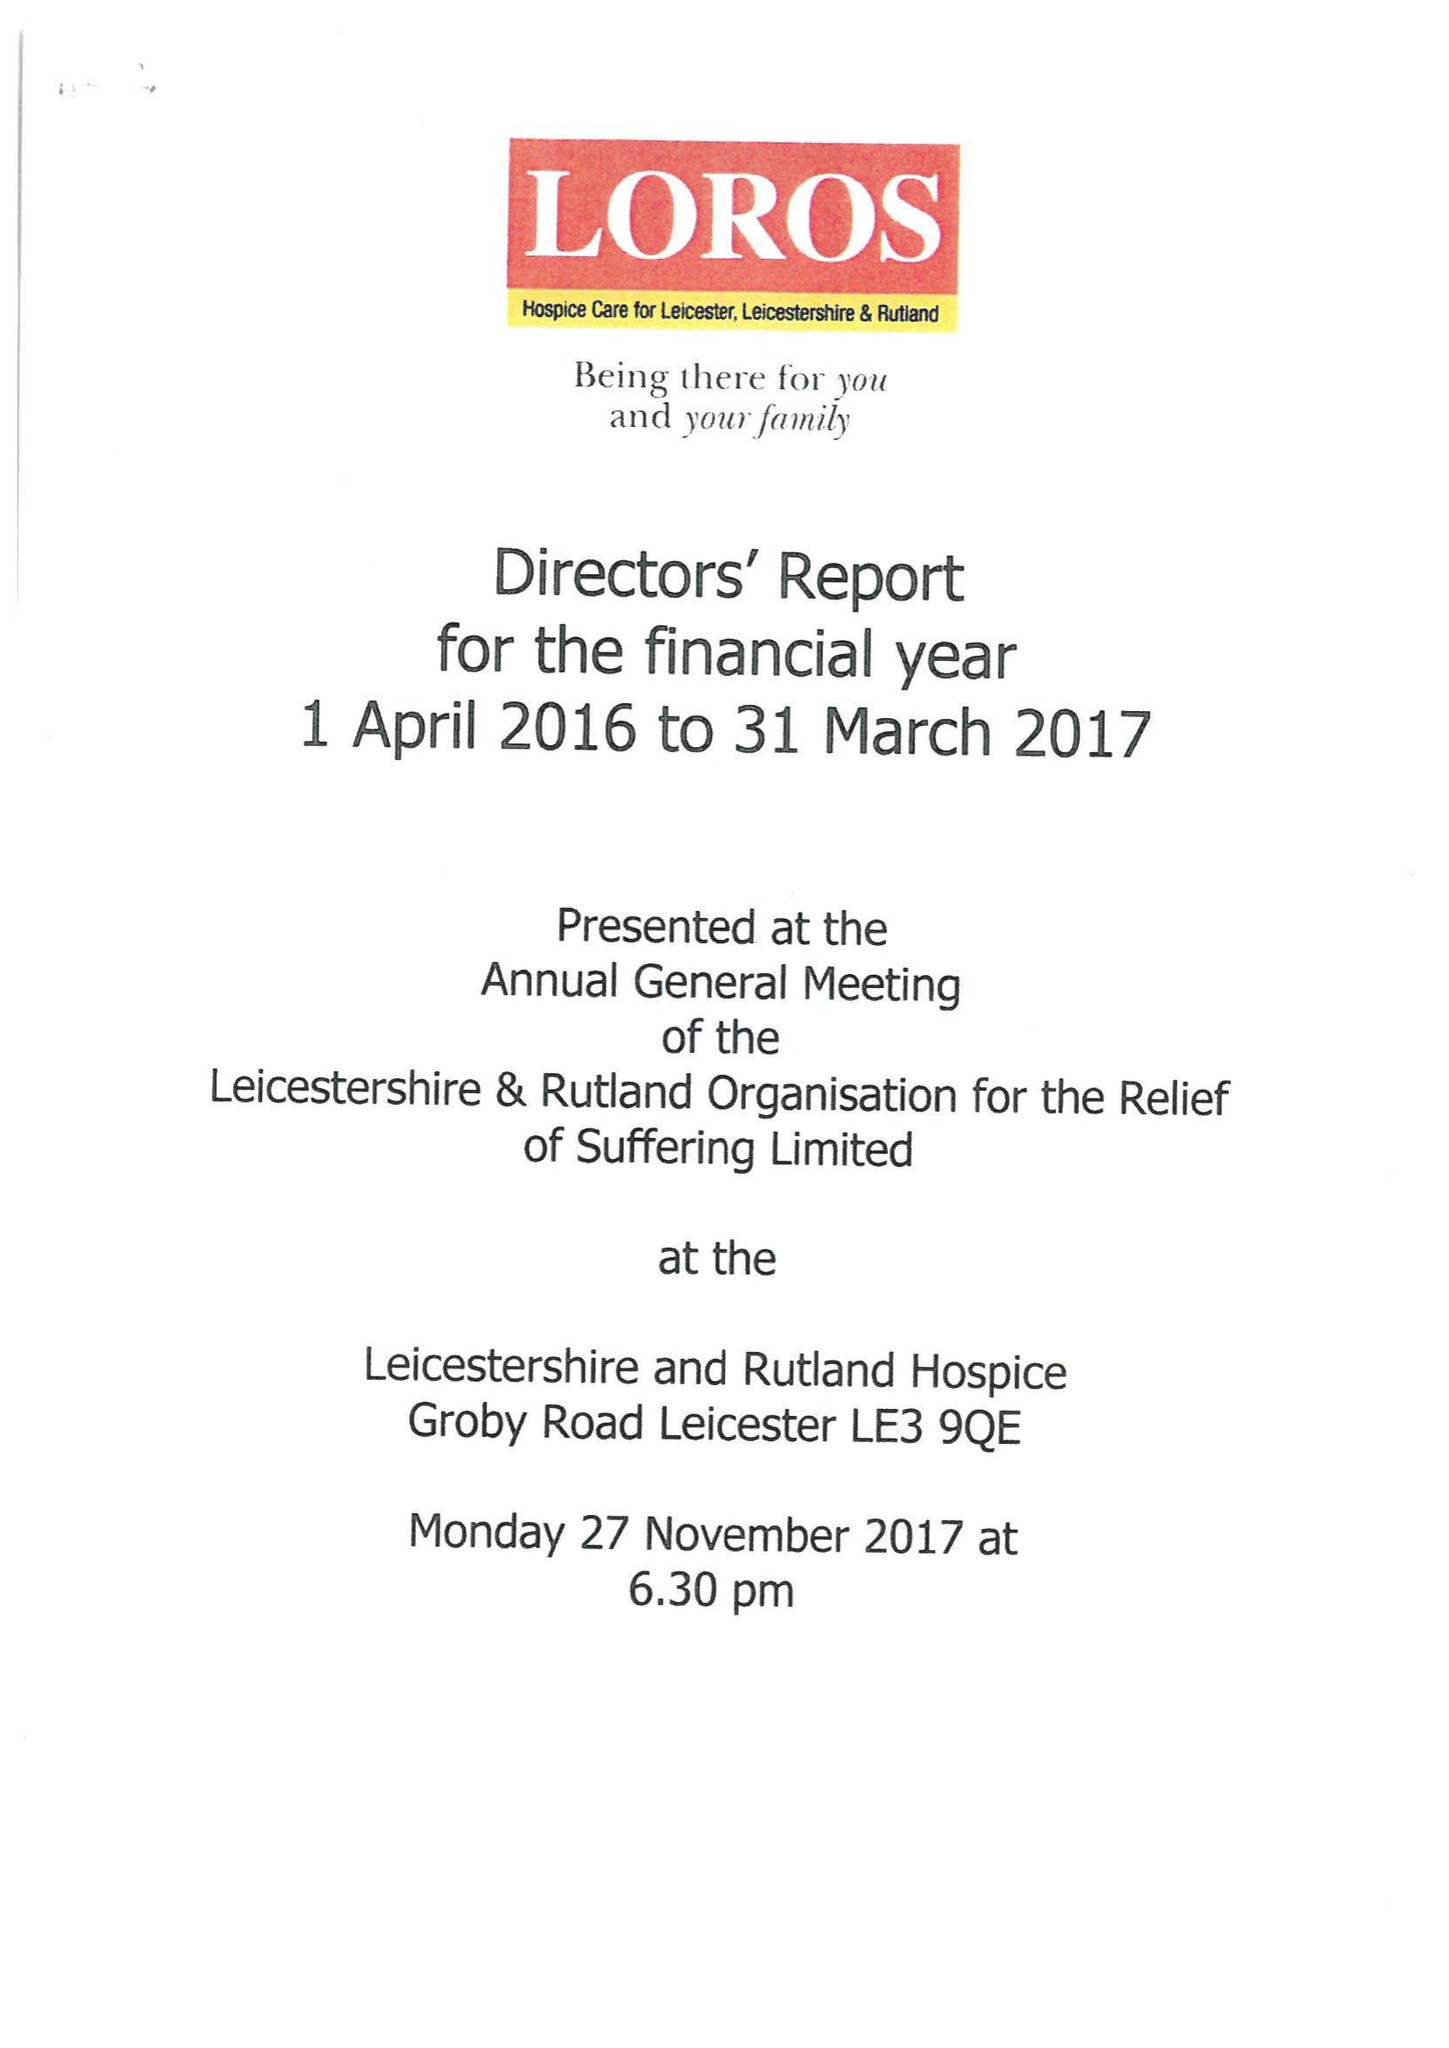What is the value for the address__postcode?
Answer the question using a single word or phrase. LE3 9QE 